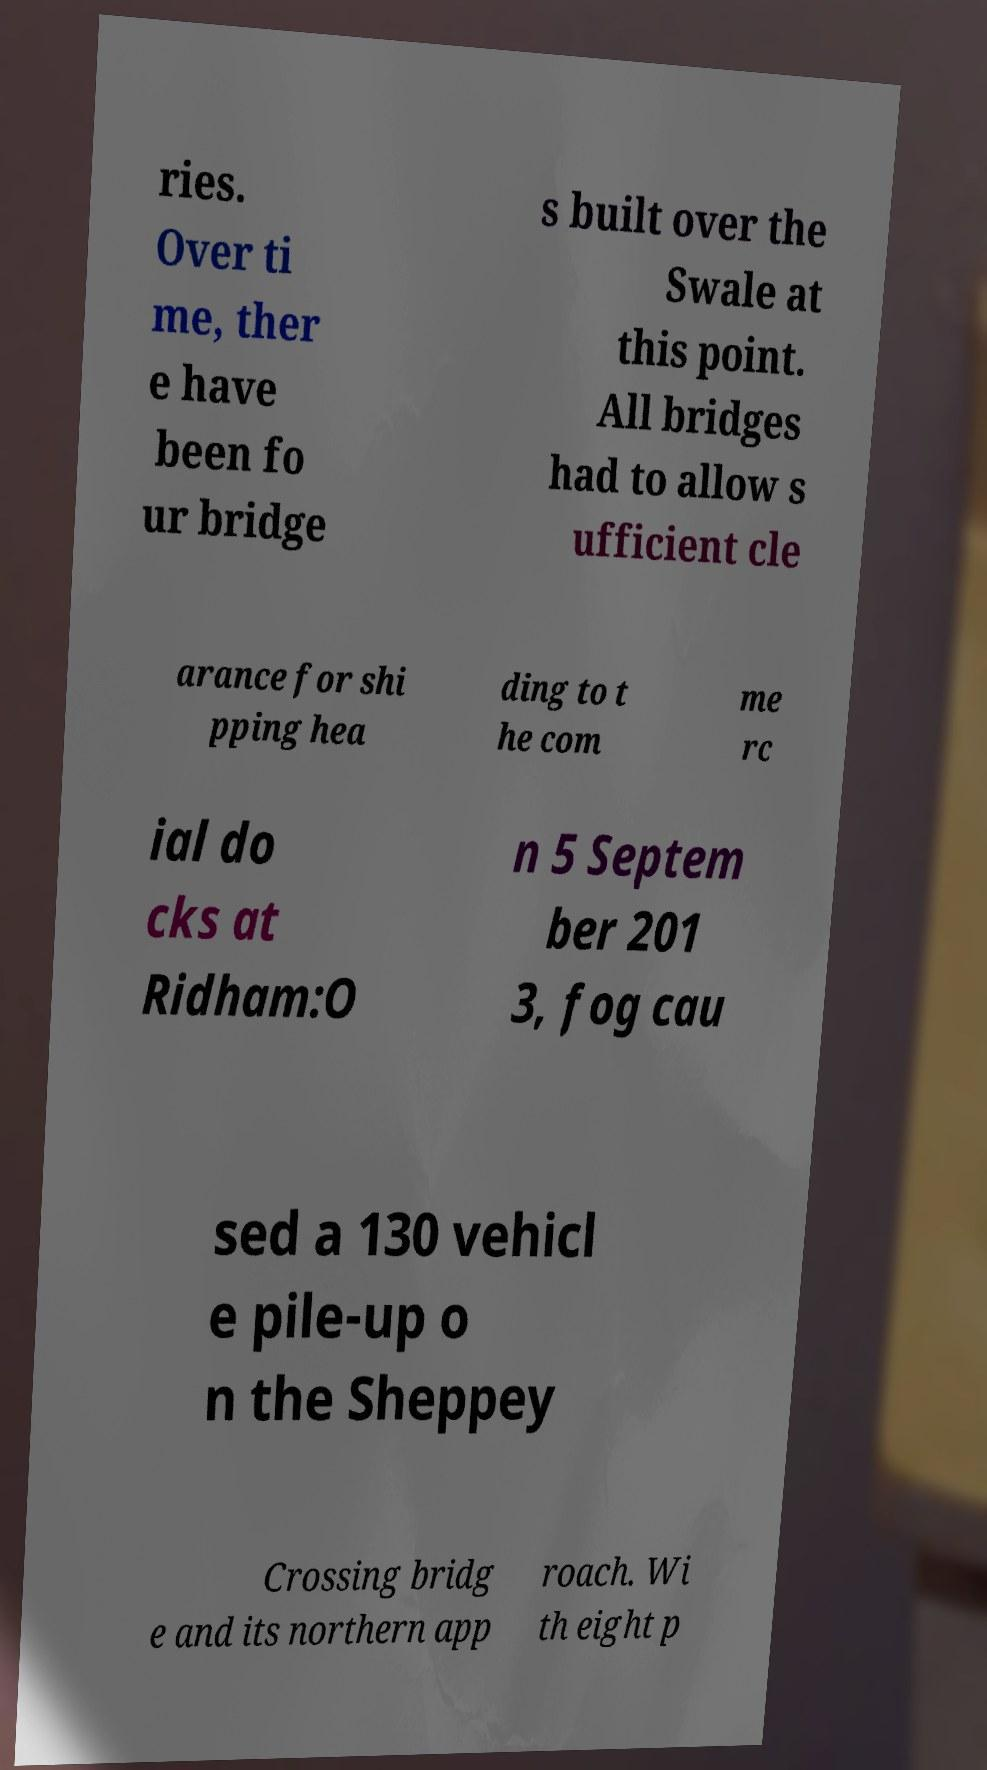There's text embedded in this image that I need extracted. Can you transcribe it verbatim? ries. Over ti me, ther e have been fo ur bridge s built over the Swale at this point. All bridges had to allow s ufficient cle arance for shi pping hea ding to t he com me rc ial do cks at Ridham:O n 5 Septem ber 201 3, fog cau sed a 130 vehicl e pile-up o n the Sheppey Crossing bridg e and its northern app roach. Wi th eight p 